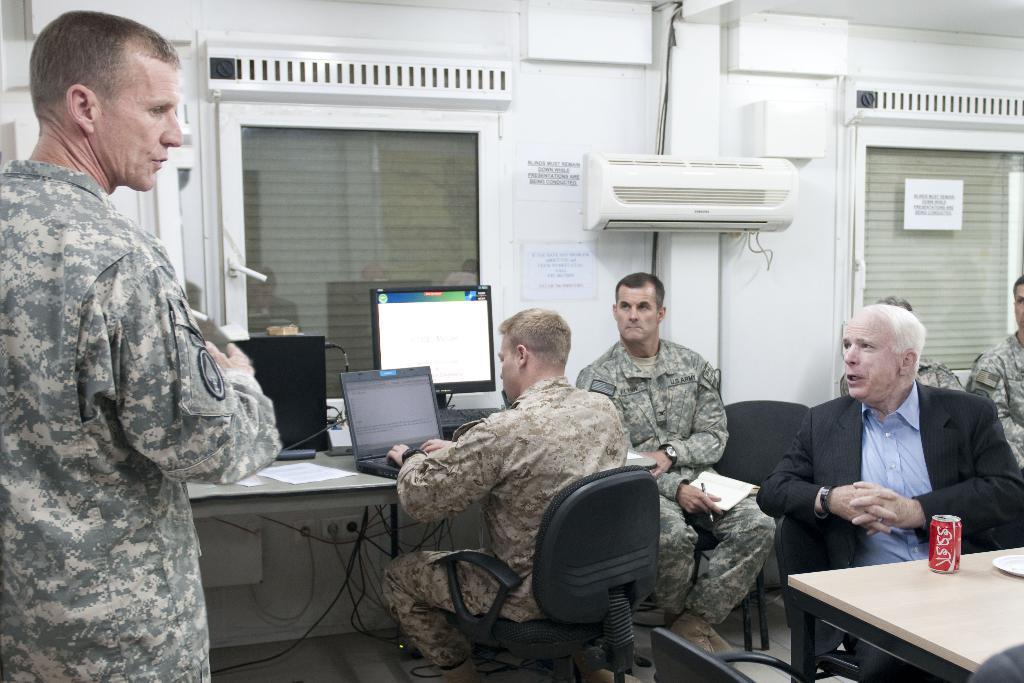Please provide a concise description of this image. In this image i can see a man standing at right i can see few other people sitting and a man working on a laptop at the back ground i can see a window and a wall. 